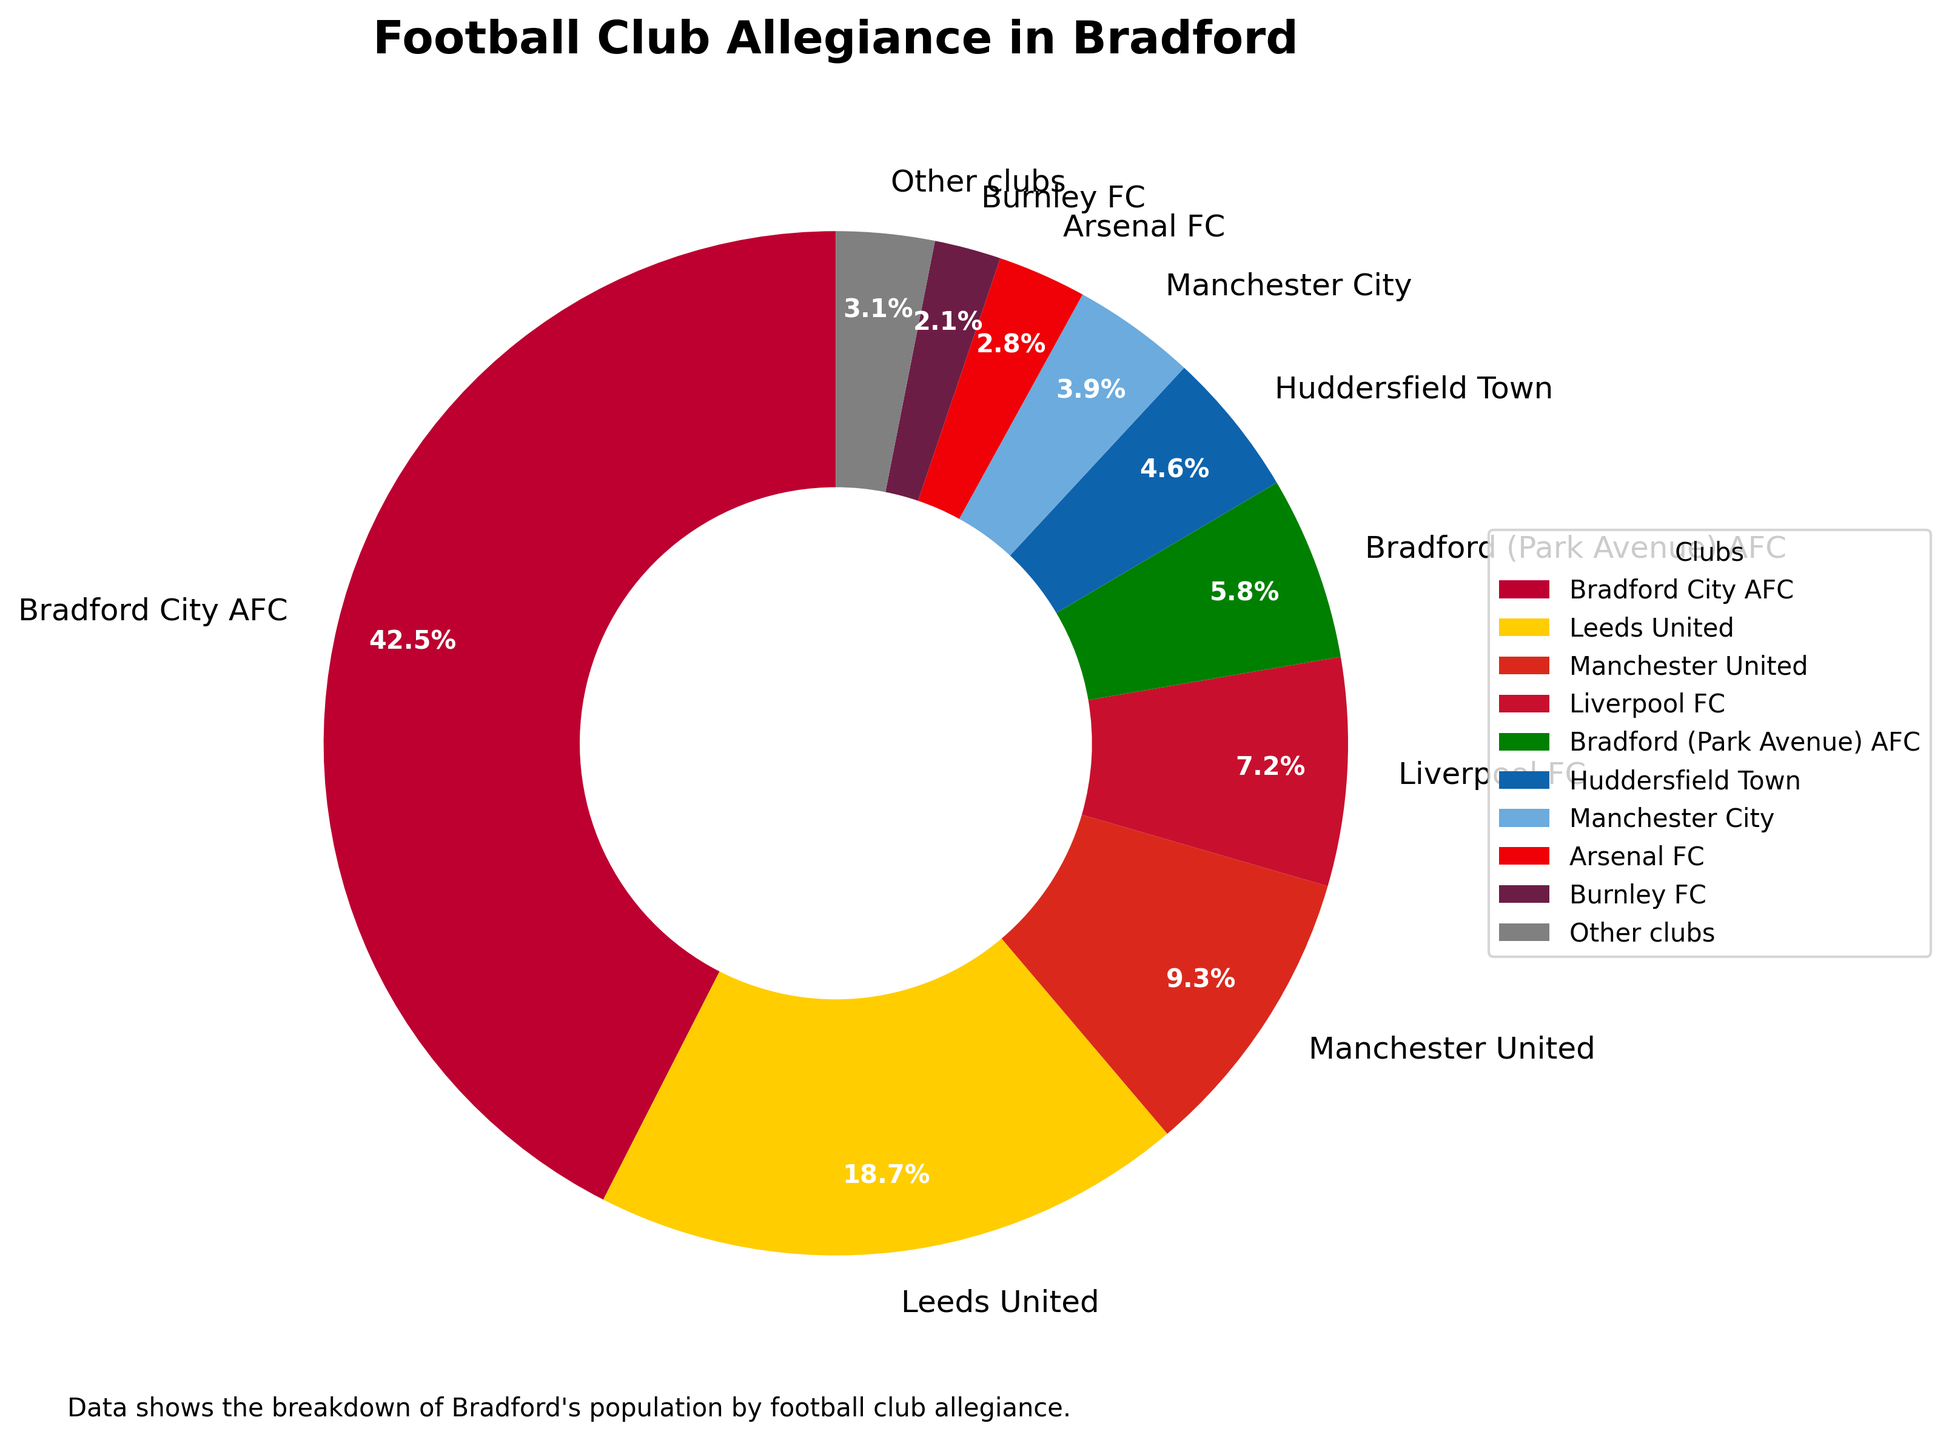Which football club has the highest percentage of allegiance in Bradford? The pie chart shows various clubs and their corresponding percentages. The highest percentage is allocated to Bradford City AFC with 42.5%, making it the club with the highest allegiance.
Answer: Bradford City AFC What is the combined percentage of people supporting Leeds United and Manchester United? Find the percentages for Leeds United (18.7%) and Manchester United (9.3%) from the chart. Add these two percentages together: 18.7% + 9.3% = 28%.
Answer: 28% Which club has a larger allegiance in Bradford, Liverpool FC or Bradford (Park Avenue) AFC? Compare the percentages for Liverpool FC (7.2%) and Bradford (Park Avenue) AFC (5.8%). Since 7.2% is greater than 5.8%, Liverpool FC has a larger allegiance.
Answer: Liverpool FC Are fans of Burnley FC more or less than those of Arsenal FC? The chart shows that Burnley FC has 2.1% and Arsenal FC has 2.8%. Since 2.1% is less than 2.8%, fans of Burnley FC are fewer than those of Arsenal FC.
Answer: Less What's the total percentage of allegiance for the clubs outside the top three? The top three clubs are Bradford City AFC (42.5%), Leeds United (18.7%), and Manchester United (9.3%). First, sum their percentages: 42.5% + 18.7% + 9.3% = 70.5%. Then, subtract from 100% to find the remaining percentage: 100% - 70.5% = 29.5%.
Answer: 29.5% If the support for Huddersfield Town doubled, what would their new percentage be and how would it compare to Manchester United's current percentage? Double the percentage for Huddersfield Town, which is 4.6%. So, 4.6% * 2 = 9.2%. Compare this to Manchester United's percentage, which is 9.3%. Since 9.2% is slightly less than 9.3%, Huddersfield Town's new percentage would still be less than Manchester United's.
Answer: 9.2%, less What is the difference in the percentage of supporters between the most and least popular clubs on the chart? Identify the most popular club (Bradford City AFC with 42.5%) and the least popular club (Burnley FC with 2.1%). Calculate the difference: 42.5% - 2.1% = 40.4%.
Answer: 40.4% Which color represents Leeds United on the chart, and what is its percentage? Leeds United is the second segment of the pie chart, colored yellow. Its percentage is 18.7%.
Answer: Yellow, 18.7% 